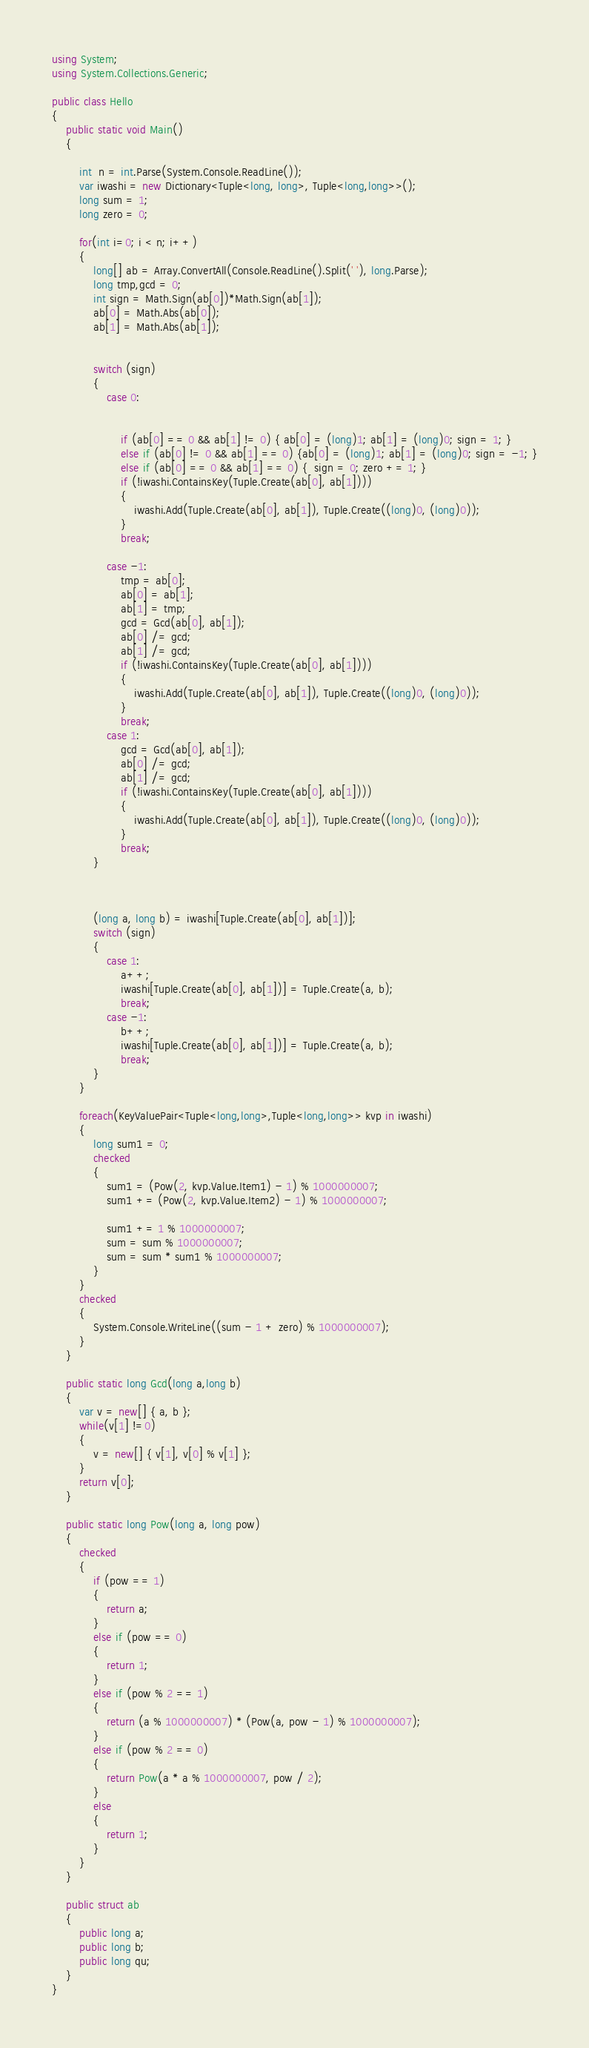Convert code to text. <code><loc_0><loc_0><loc_500><loc_500><_C#_>using System;
using System.Collections.Generic;

public class Hello
{
    public static void Main()
    {

        int  n = int.Parse(System.Console.ReadLine());
        var iwashi = new Dictionary<Tuple<long, long>, Tuple<long,long>>();
        long sum = 1;
        long zero = 0;

        for(int i=0; i < n; i++)
        {
            long[] ab = Array.ConvertAll(Console.ReadLine().Split(' '), long.Parse);
            long tmp,gcd = 0;
            int sign = Math.Sign(ab[0])*Math.Sign(ab[1]);
            ab[0] = Math.Abs(ab[0]);
            ab[1] = Math.Abs(ab[1]);


            switch (sign)
            {
                case 0:


                    if (ab[0] == 0 && ab[1] != 0) { ab[0] = (long)1; ab[1] = (long)0; sign = 1; }
                    else if (ab[0] != 0 && ab[1] == 0) {ab[0] = (long)1; ab[1] = (long)0; sign = -1; }
                    else if (ab[0] == 0 && ab[1] == 0) {  sign = 0; zero += 1; }
                    if (!iwashi.ContainsKey(Tuple.Create(ab[0], ab[1])))
                    {
                        iwashi.Add(Tuple.Create(ab[0], ab[1]), Tuple.Create((long)0, (long)0));
                    }
                    break;

                case -1:
                    tmp = ab[0];
                    ab[0] = ab[1];
                    ab[1] = tmp;
                    gcd = Gcd(ab[0], ab[1]);
                    ab[0] /= gcd;
                    ab[1] /= gcd;
                    if (!iwashi.ContainsKey(Tuple.Create(ab[0], ab[1])))
                    {
                        iwashi.Add(Tuple.Create(ab[0], ab[1]), Tuple.Create((long)0, (long)0));
                    }
                    break;
                case 1:
                    gcd = Gcd(ab[0], ab[1]);
                    ab[0] /= gcd;
                    ab[1] /= gcd;
                    if (!iwashi.ContainsKey(Tuple.Create(ab[0], ab[1])))
                    {
                        iwashi.Add(Tuple.Create(ab[0], ab[1]), Tuple.Create((long)0, (long)0));
                    }
                    break;
            }



            (long a, long b) = iwashi[Tuple.Create(ab[0], ab[1])];
            switch (sign)
            {
                case 1:
                    a++;
                    iwashi[Tuple.Create(ab[0], ab[1])] = Tuple.Create(a, b);
                    break;
                case -1:
                    b++;
                    iwashi[Tuple.Create(ab[0], ab[1])] = Tuple.Create(a, b);
                    break;
            }
        }
        
        foreach(KeyValuePair<Tuple<long,long>,Tuple<long,long>> kvp in iwashi)
        {
            long sum1 = 0;
            checked
            {
                sum1 = (Pow(2, kvp.Value.Item1) - 1) % 1000000007;
                sum1 += (Pow(2, kvp.Value.Item2) - 1) % 1000000007;
          
                sum1 += 1 % 1000000007;
                sum = sum % 1000000007;
                sum = sum * sum1 % 1000000007;
            }
        }
        checked
        {
            System.Console.WriteLine((sum - 1 + zero) % 1000000007);
        }
    }

    public static long Gcd(long a,long b)
    {
        var v = new[] { a, b };
        while(v[1] !=0)
        {
            v = new[] { v[1], v[0] % v[1] };
        }
        return v[0];
    }

    public static long Pow(long a, long pow)
    {
        checked
        {
            if (pow == 1)
            {
                return a;
            }
            else if (pow == 0)
            {
                return 1;
            }
            else if (pow % 2 == 1)
            {
                return (a % 1000000007) * (Pow(a, pow - 1) % 1000000007);
            }
            else if (pow % 2 == 0)
            {
                return Pow(a * a % 1000000007, pow / 2);
            }
            else
            {
                return 1;
            }
        }
    }

    public struct ab
    {
        public long a;
        public long b;
        public long qu;
    }
}</code> 